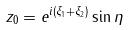Convert formula to latex. <formula><loc_0><loc_0><loc_500><loc_500>z _ { 0 } = e ^ { i ( \xi _ { 1 } + \xi _ { 2 } ) } \sin \eta</formula> 